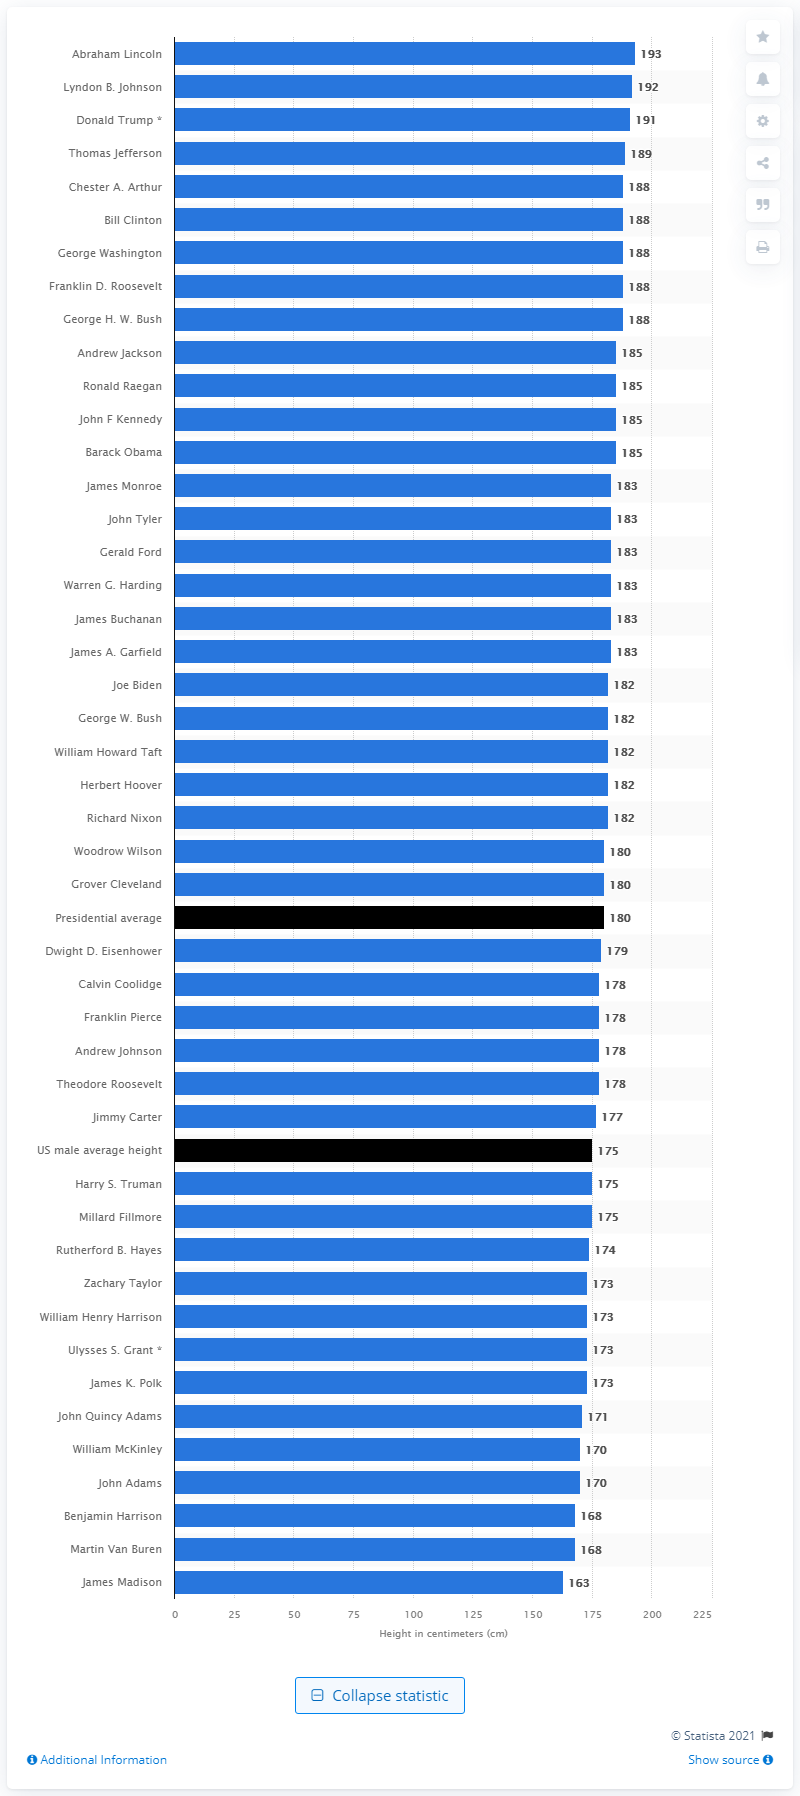Point out several critical features in this image. James Madison was the shortest U.S. president in history. Abraham Lincoln was the tallest U.S. president in history. 